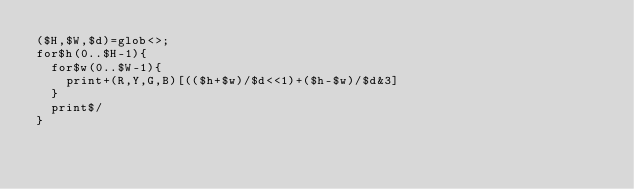<code> <loc_0><loc_0><loc_500><loc_500><_Perl_>($H,$W,$d)=glob<>;
for$h(0..$H-1){
	for$w(0..$W-1){
		print+(R,Y,G,B)[(($h+$w)/$d<<1)+($h-$w)/$d&3]
	}
	print$/
}
</code> 